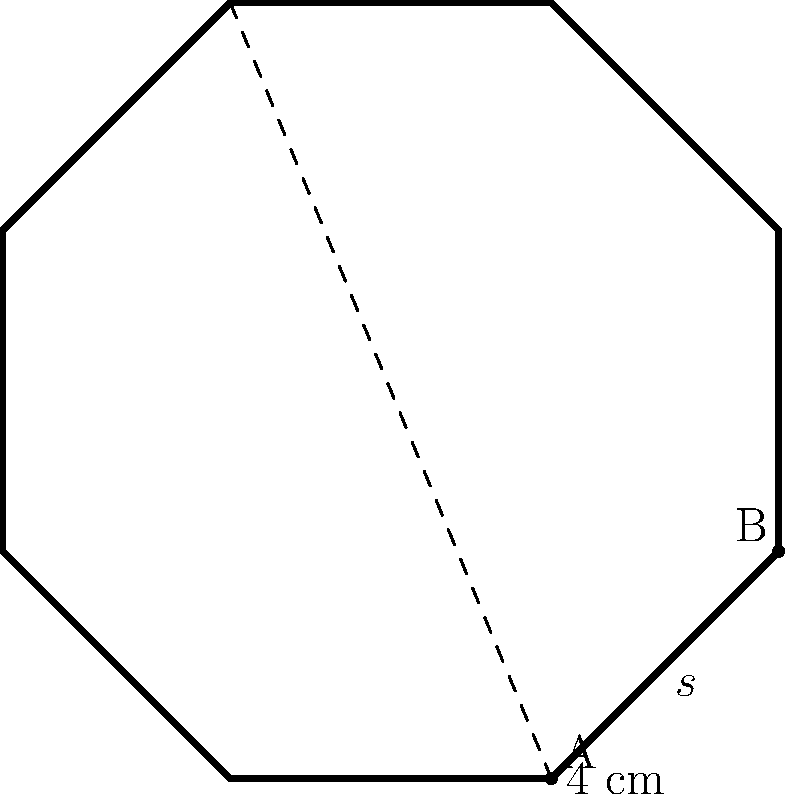A client wants an octagonal profile picture frame for their social media account. The frame has a side length of 4 cm. Calculate the perimeter of the octagonal frame to determine the amount of material needed for its border. To find the perimeter of the octagonal frame, we need to follow these steps:

1) Recall the formula for the perimeter of a regular octagon:
   $$P = 8s$$
   where $P$ is the perimeter and $s$ is the side length.

2) We are given that the side length is 4 cm.

3) Substitute this value into the formula:
   $$P = 8 \times 4$$

4) Calculate:
   $$P = 32$$

Therefore, the perimeter of the octagonal frame is 32 cm.
Answer: 32 cm 